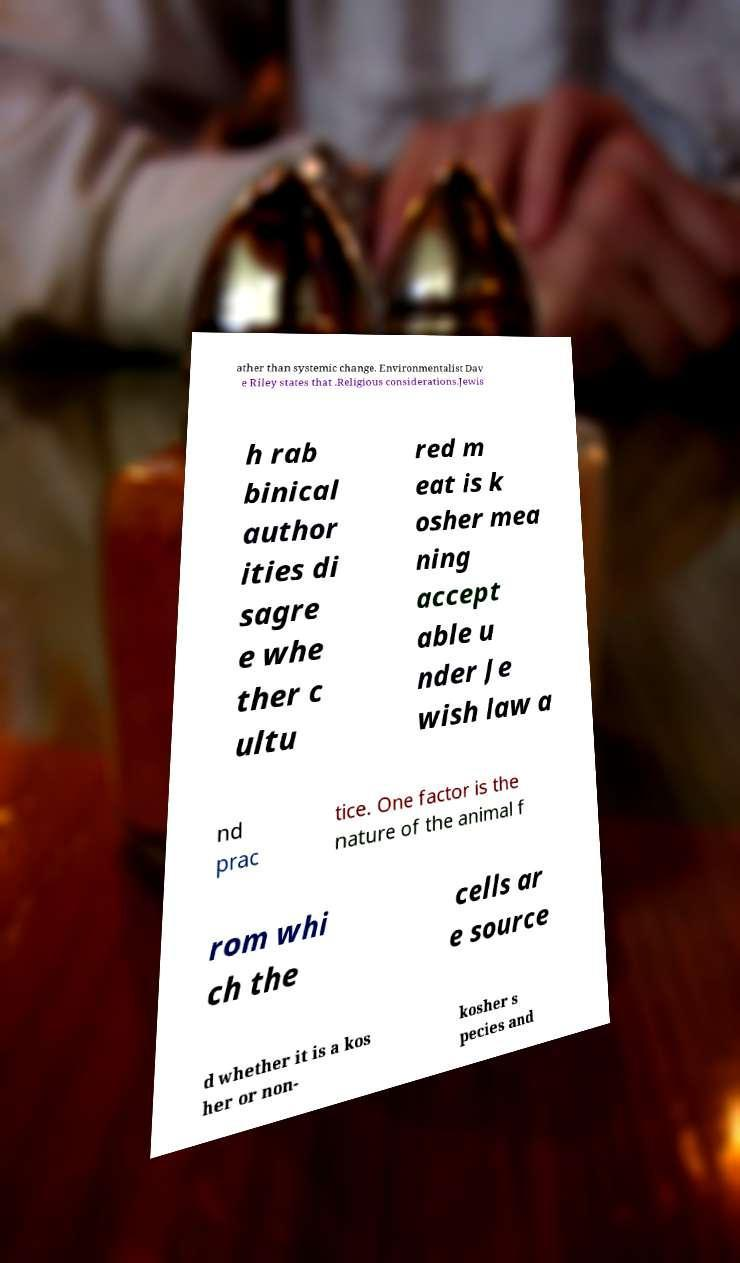Could you assist in decoding the text presented in this image and type it out clearly? ather than systemic change. Environmentalist Dav e Riley states that .Religious considerations.Jewis h rab binical author ities di sagre e whe ther c ultu red m eat is k osher mea ning accept able u nder Je wish law a nd prac tice. One factor is the nature of the animal f rom whi ch the cells ar e source d whether it is a kos her or non- kosher s pecies and 